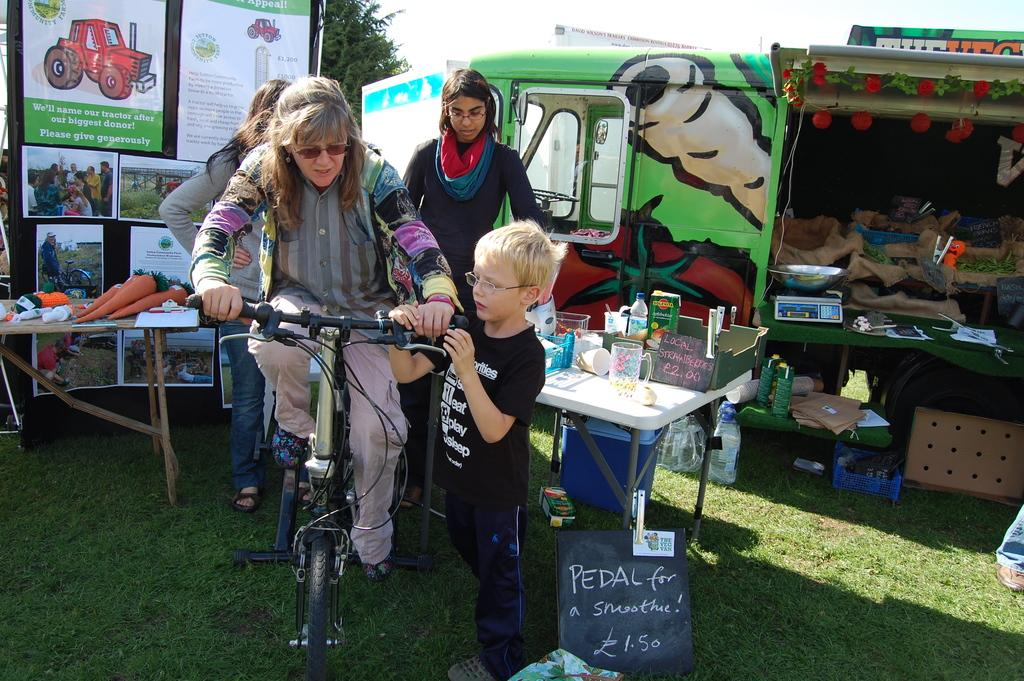What is the old woman doing in the image? The old woman is riding a cycle in the image. Who is with the old woman in the image? A boy is standing beside the cycle. What is the boy doing in the image? The boy is holding the cycle. What is the boy wearing in the image? The boy is wearing a black t-shirt. What can be seen in the background of the image? There are banners visible in the background of the image, as well as other unspecified objects. How is the tray being distributed in the image? There is no tray present in the image, so it cannot be distributed. 